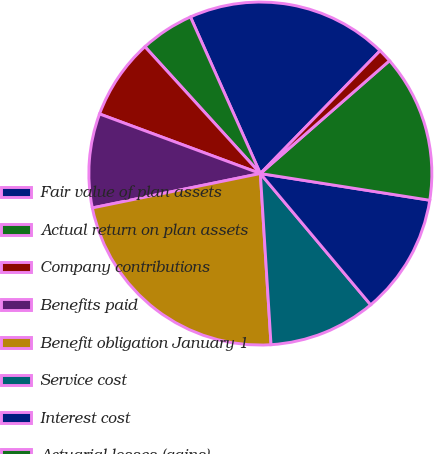Convert chart to OTSL. <chart><loc_0><loc_0><loc_500><loc_500><pie_chart><fcel>Fair value of plan assets<fcel>Actual return on plan assets<fcel>Company contributions<fcel>Benefits paid<fcel>Benefit obligation January 1<fcel>Service cost<fcel>Interest cost<fcel>Actuarial losses (gains)<fcel>Effects of exchange rate<nl><fcel>18.98%<fcel>5.07%<fcel>7.6%<fcel>8.86%<fcel>22.78%<fcel>10.13%<fcel>11.39%<fcel>13.92%<fcel>1.27%<nl></chart> 